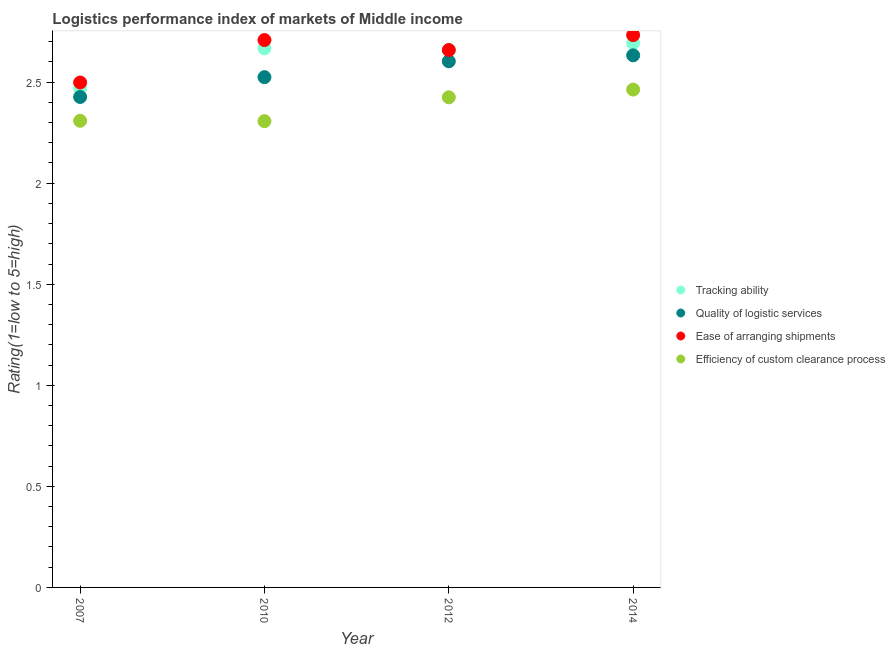How many different coloured dotlines are there?
Offer a very short reply. 4. Is the number of dotlines equal to the number of legend labels?
Provide a succinct answer. Yes. What is the lpi rating of efficiency of custom clearance process in 2007?
Make the answer very short. 2.31. Across all years, what is the maximum lpi rating of quality of logistic services?
Your response must be concise. 2.63. Across all years, what is the minimum lpi rating of tracking ability?
Ensure brevity in your answer.  2.47. In which year was the lpi rating of quality of logistic services minimum?
Provide a short and direct response. 2007. What is the total lpi rating of efficiency of custom clearance process in the graph?
Your answer should be compact. 9.5. What is the difference between the lpi rating of efficiency of custom clearance process in 2007 and that in 2012?
Keep it short and to the point. -0.12. What is the difference between the lpi rating of efficiency of custom clearance process in 2014 and the lpi rating of tracking ability in 2012?
Provide a short and direct response. -0.2. What is the average lpi rating of quality of logistic services per year?
Your response must be concise. 2.55. In the year 2007, what is the difference between the lpi rating of ease of arranging shipments and lpi rating of tracking ability?
Your response must be concise. 0.03. In how many years, is the lpi rating of tracking ability greater than 0.30000000000000004?
Your response must be concise. 4. What is the ratio of the lpi rating of tracking ability in 2010 to that in 2012?
Ensure brevity in your answer.  1. Is the difference between the lpi rating of efficiency of custom clearance process in 2012 and 2014 greater than the difference between the lpi rating of quality of logistic services in 2012 and 2014?
Offer a very short reply. No. What is the difference between the highest and the second highest lpi rating of ease of arranging shipments?
Provide a succinct answer. 0.02. What is the difference between the highest and the lowest lpi rating of quality of logistic services?
Ensure brevity in your answer.  0.21. In how many years, is the lpi rating of quality of logistic services greater than the average lpi rating of quality of logistic services taken over all years?
Provide a succinct answer. 2. Is it the case that in every year, the sum of the lpi rating of quality of logistic services and lpi rating of ease of arranging shipments is greater than the sum of lpi rating of tracking ability and lpi rating of efficiency of custom clearance process?
Provide a short and direct response. No. Does the lpi rating of tracking ability monotonically increase over the years?
Your answer should be compact. No. How many years are there in the graph?
Offer a very short reply. 4. Where does the legend appear in the graph?
Ensure brevity in your answer.  Center right. What is the title of the graph?
Provide a succinct answer. Logistics performance index of markets of Middle income. Does "Business regulatory environment" appear as one of the legend labels in the graph?
Provide a succinct answer. No. What is the label or title of the X-axis?
Keep it short and to the point. Year. What is the label or title of the Y-axis?
Your answer should be compact. Rating(1=low to 5=high). What is the Rating(1=low to 5=high) in Tracking ability in 2007?
Keep it short and to the point. 2.47. What is the Rating(1=low to 5=high) in Quality of logistic services in 2007?
Keep it short and to the point. 2.43. What is the Rating(1=low to 5=high) of Ease of arranging shipments in 2007?
Provide a short and direct response. 2.5. What is the Rating(1=low to 5=high) in Efficiency of custom clearance process in 2007?
Offer a very short reply. 2.31. What is the Rating(1=low to 5=high) in Tracking ability in 2010?
Offer a terse response. 2.67. What is the Rating(1=low to 5=high) of Quality of logistic services in 2010?
Give a very brief answer. 2.52. What is the Rating(1=low to 5=high) of Ease of arranging shipments in 2010?
Provide a short and direct response. 2.71. What is the Rating(1=low to 5=high) in Efficiency of custom clearance process in 2010?
Your answer should be very brief. 2.31. What is the Rating(1=low to 5=high) of Tracking ability in 2012?
Provide a short and direct response. 2.66. What is the Rating(1=low to 5=high) of Quality of logistic services in 2012?
Provide a succinct answer. 2.6. What is the Rating(1=low to 5=high) of Ease of arranging shipments in 2012?
Give a very brief answer. 2.66. What is the Rating(1=low to 5=high) of Efficiency of custom clearance process in 2012?
Provide a short and direct response. 2.42. What is the Rating(1=low to 5=high) of Tracking ability in 2014?
Make the answer very short. 2.69. What is the Rating(1=low to 5=high) of Quality of logistic services in 2014?
Make the answer very short. 2.63. What is the Rating(1=low to 5=high) of Ease of arranging shipments in 2014?
Your answer should be very brief. 2.73. What is the Rating(1=low to 5=high) in Efficiency of custom clearance process in 2014?
Provide a succinct answer. 2.46. Across all years, what is the maximum Rating(1=low to 5=high) in Tracking ability?
Your answer should be compact. 2.69. Across all years, what is the maximum Rating(1=low to 5=high) of Quality of logistic services?
Offer a very short reply. 2.63. Across all years, what is the maximum Rating(1=low to 5=high) of Ease of arranging shipments?
Offer a very short reply. 2.73. Across all years, what is the maximum Rating(1=low to 5=high) in Efficiency of custom clearance process?
Provide a succinct answer. 2.46. Across all years, what is the minimum Rating(1=low to 5=high) in Tracking ability?
Give a very brief answer. 2.47. Across all years, what is the minimum Rating(1=low to 5=high) of Quality of logistic services?
Your answer should be very brief. 2.43. Across all years, what is the minimum Rating(1=low to 5=high) in Ease of arranging shipments?
Make the answer very short. 2.5. Across all years, what is the minimum Rating(1=low to 5=high) in Efficiency of custom clearance process?
Provide a succinct answer. 2.31. What is the total Rating(1=low to 5=high) of Tracking ability in the graph?
Your answer should be very brief. 10.49. What is the total Rating(1=low to 5=high) of Quality of logistic services in the graph?
Ensure brevity in your answer.  10.19. What is the total Rating(1=low to 5=high) in Ease of arranging shipments in the graph?
Give a very brief answer. 10.6. What is the total Rating(1=low to 5=high) of Efficiency of custom clearance process in the graph?
Offer a terse response. 9.5. What is the difference between the Rating(1=low to 5=high) in Tracking ability in 2007 and that in 2010?
Ensure brevity in your answer.  -0.2. What is the difference between the Rating(1=low to 5=high) of Quality of logistic services in 2007 and that in 2010?
Ensure brevity in your answer.  -0.1. What is the difference between the Rating(1=low to 5=high) in Ease of arranging shipments in 2007 and that in 2010?
Keep it short and to the point. -0.21. What is the difference between the Rating(1=low to 5=high) in Efficiency of custom clearance process in 2007 and that in 2010?
Make the answer very short. 0. What is the difference between the Rating(1=low to 5=high) in Tracking ability in 2007 and that in 2012?
Ensure brevity in your answer.  -0.19. What is the difference between the Rating(1=low to 5=high) in Quality of logistic services in 2007 and that in 2012?
Your answer should be compact. -0.18. What is the difference between the Rating(1=low to 5=high) in Ease of arranging shipments in 2007 and that in 2012?
Your response must be concise. -0.16. What is the difference between the Rating(1=low to 5=high) of Efficiency of custom clearance process in 2007 and that in 2012?
Provide a succinct answer. -0.12. What is the difference between the Rating(1=low to 5=high) in Tracking ability in 2007 and that in 2014?
Provide a short and direct response. -0.22. What is the difference between the Rating(1=low to 5=high) in Quality of logistic services in 2007 and that in 2014?
Offer a terse response. -0.21. What is the difference between the Rating(1=low to 5=high) of Ease of arranging shipments in 2007 and that in 2014?
Keep it short and to the point. -0.23. What is the difference between the Rating(1=low to 5=high) of Efficiency of custom clearance process in 2007 and that in 2014?
Keep it short and to the point. -0.15. What is the difference between the Rating(1=low to 5=high) of Tracking ability in 2010 and that in 2012?
Make the answer very short. 0.01. What is the difference between the Rating(1=low to 5=high) in Quality of logistic services in 2010 and that in 2012?
Your response must be concise. -0.08. What is the difference between the Rating(1=low to 5=high) in Ease of arranging shipments in 2010 and that in 2012?
Offer a very short reply. 0.05. What is the difference between the Rating(1=low to 5=high) in Efficiency of custom clearance process in 2010 and that in 2012?
Offer a terse response. -0.12. What is the difference between the Rating(1=low to 5=high) in Tracking ability in 2010 and that in 2014?
Offer a terse response. -0.03. What is the difference between the Rating(1=low to 5=high) of Quality of logistic services in 2010 and that in 2014?
Offer a very short reply. -0.11. What is the difference between the Rating(1=low to 5=high) in Ease of arranging shipments in 2010 and that in 2014?
Keep it short and to the point. -0.02. What is the difference between the Rating(1=low to 5=high) of Efficiency of custom clearance process in 2010 and that in 2014?
Your response must be concise. -0.16. What is the difference between the Rating(1=low to 5=high) in Tracking ability in 2012 and that in 2014?
Ensure brevity in your answer.  -0.03. What is the difference between the Rating(1=low to 5=high) of Quality of logistic services in 2012 and that in 2014?
Keep it short and to the point. -0.03. What is the difference between the Rating(1=low to 5=high) of Ease of arranging shipments in 2012 and that in 2014?
Offer a very short reply. -0.07. What is the difference between the Rating(1=low to 5=high) of Efficiency of custom clearance process in 2012 and that in 2014?
Your answer should be compact. -0.04. What is the difference between the Rating(1=low to 5=high) of Tracking ability in 2007 and the Rating(1=low to 5=high) of Quality of logistic services in 2010?
Make the answer very short. -0.06. What is the difference between the Rating(1=low to 5=high) of Tracking ability in 2007 and the Rating(1=low to 5=high) of Ease of arranging shipments in 2010?
Keep it short and to the point. -0.24. What is the difference between the Rating(1=low to 5=high) of Tracking ability in 2007 and the Rating(1=low to 5=high) of Efficiency of custom clearance process in 2010?
Ensure brevity in your answer.  0.16. What is the difference between the Rating(1=low to 5=high) in Quality of logistic services in 2007 and the Rating(1=low to 5=high) in Ease of arranging shipments in 2010?
Your answer should be very brief. -0.28. What is the difference between the Rating(1=low to 5=high) in Quality of logistic services in 2007 and the Rating(1=low to 5=high) in Efficiency of custom clearance process in 2010?
Offer a terse response. 0.12. What is the difference between the Rating(1=low to 5=high) of Ease of arranging shipments in 2007 and the Rating(1=low to 5=high) of Efficiency of custom clearance process in 2010?
Your answer should be very brief. 0.19. What is the difference between the Rating(1=low to 5=high) in Tracking ability in 2007 and the Rating(1=low to 5=high) in Quality of logistic services in 2012?
Offer a very short reply. -0.13. What is the difference between the Rating(1=low to 5=high) of Tracking ability in 2007 and the Rating(1=low to 5=high) of Ease of arranging shipments in 2012?
Offer a very short reply. -0.19. What is the difference between the Rating(1=low to 5=high) of Tracking ability in 2007 and the Rating(1=low to 5=high) of Efficiency of custom clearance process in 2012?
Keep it short and to the point. 0.04. What is the difference between the Rating(1=low to 5=high) of Quality of logistic services in 2007 and the Rating(1=low to 5=high) of Ease of arranging shipments in 2012?
Keep it short and to the point. -0.23. What is the difference between the Rating(1=low to 5=high) in Quality of logistic services in 2007 and the Rating(1=low to 5=high) in Efficiency of custom clearance process in 2012?
Provide a succinct answer. 0. What is the difference between the Rating(1=low to 5=high) in Ease of arranging shipments in 2007 and the Rating(1=low to 5=high) in Efficiency of custom clearance process in 2012?
Give a very brief answer. 0.07. What is the difference between the Rating(1=low to 5=high) in Tracking ability in 2007 and the Rating(1=low to 5=high) in Quality of logistic services in 2014?
Keep it short and to the point. -0.16. What is the difference between the Rating(1=low to 5=high) of Tracking ability in 2007 and the Rating(1=low to 5=high) of Ease of arranging shipments in 2014?
Offer a very short reply. -0.26. What is the difference between the Rating(1=low to 5=high) in Tracking ability in 2007 and the Rating(1=low to 5=high) in Efficiency of custom clearance process in 2014?
Keep it short and to the point. 0.01. What is the difference between the Rating(1=low to 5=high) in Quality of logistic services in 2007 and the Rating(1=low to 5=high) in Ease of arranging shipments in 2014?
Your answer should be very brief. -0.31. What is the difference between the Rating(1=low to 5=high) of Quality of logistic services in 2007 and the Rating(1=low to 5=high) of Efficiency of custom clearance process in 2014?
Give a very brief answer. -0.04. What is the difference between the Rating(1=low to 5=high) in Ease of arranging shipments in 2007 and the Rating(1=low to 5=high) in Efficiency of custom clearance process in 2014?
Offer a terse response. 0.04. What is the difference between the Rating(1=low to 5=high) of Tracking ability in 2010 and the Rating(1=low to 5=high) of Quality of logistic services in 2012?
Keep it short and to the point. 0.06. What is the difference between the Rating(1=low to 5=high) in Tracking ability in 2010 and the Rating(1=low to 5=high) in Ease of arranging shipments in 2012?
Give a very brief answer. 0.01. What is the difference between the Rating(1=low to 5=high) in Tracking ability in 2010 and the Rating(1=low to 5=high) in Efficiency of custom clearance process in 2012?
Keep it short and to the point. 0.24. What is the difference between the Rating(1=low to 5=high) of Quality of logistic services in 2010 and the Rating(1=low to 5=high) of Ease of arranging shipments in 2012?
Your answer should be compact. -0.13. What is the difference between the Rating(1=low to 5=high) in Quality of logistic services in 2010 and the Rating(1=low to 5=high) in Efficiency of custom clearance process in 2012?
Keep it short and to the point. 0.1. What is the difference between the Rating(1=low to 5=high) in Ease of arranging shipments in 2010 and the Rating(1=low to 5=high) in Efficiency of custom clearance process in 2012?
Your answer should be compact. 0.28. What is the difference between the Rating(1=low to 5=high) in Tracking ability in 2010 and the Rating(1=low to 5=high) in Quality of logistic services in 2014?
Ensure brevity in your answer.  0.03. What is the difference between the Rating(1=low to 5=high) in Tracking ability in 2010 and the Rating(1=low to 5=high) in Ease of arranging shipments in 2014?
Keep it short and to the point. -0.07. What is the difference between the Rating(1=low to 5=high) in Tracking ability in 2010 and the Rating(1=low to 5=high) in Efficiency of custom clearance process in 2014?
Provide a succinct answer. 0.2. What is the difference between the Rating(1=low to 5=high) in Quality of logistic services in 2010 and the Rating(1=low to 5=high) in Ease of arranging shipments in 2014?
Give a very brief answer. -0.21. What is the difference between the Rating(1=low to 5=high) of Quality of logistic services in 2010 and the Rating(1=low to 5=high) of Efficiency of custom clearance process in 2014?
Offer a very short reply. 0.06. What is the difference between the Rating(1=low to 5=high) in Ease of arranging shipments in 2010 and the Rating(1=low to 5=high) in Efficiency of custom clearance process in 2014?
Provide a succinct answer. 0.24. What is the difference between the Rating(1=low to 5=high) of Tracking ability in 2012 and the Rating(1=low to 5=high) of Quality of logistic services in 2014?
Offer a very short reply. 0.03. What is the difference between the Rating(1=low to 5=high) of Tracking ability in 2012 and the Rating(1=low to 5=high) of Ease of arranging shipments in 2014?
Provide a short and direct response. -0.07. What is the difference between the Rating(1=low to 5=high) in Tracking ability in 2012 and the Rating(1=low to 5=high) in Efficiency of custom clearance process in 2014?
Make the answer very short. 0.2. What is the difference between the Rating(1=low to 5=high) of Quality of logistic services in 2012 and the Rating(1=low to 5=high) of Ease of arranging shipments in 2014?
Your answer should be compact. -0.13. What is the difference between the Rating(1=low to 5=high) in Quality of logistic services in 2012 and the Rating(1=low to 5=high) in Efficiency of custom clearance process in 2014?
Offer a very short reply. 0.14. What is the difference between the Rating(1=low to 5=high) of Ease of arranging shipments in 2012 and the Rating(1=low to 5=high) of Efficiency of custom clearance process in 2014?
Your answer should be very brief. 0.2. What is the average Rating(1=low to 5=high) of Tracking ability per year?
Provide a succinct answer. 2.62. What is the average Rating(1=low to 5=high) of Quality of logistic services per year?
Your answer should be compact. 2.55. What is the average Rating(1=low to 5=high) of Ease of arranging shipments per year?
Your answer should be very brief. 2.65. What is the average Rating(1=low to 5=high) of Efficiency of custom clearance process per year?
Keep it short and to the point. 2.38. In the year 2007, what is the difference between the Rating(1=low to 5=high) of Tracking ability and Rating(1=low to 5=high) of Quality of logistic services?
Your answer should be compact. 0.04. In the year 2007, what is the difference between the Rating(1=low to 5=high) in Tracking ability and Rating(1=low to 5=high) in Ease of arranging shipments?
Your response must be concise. -0.03. In the year 2007, what is the difference between the Rating(1=low to 5=high) of Tracking ability and Rating(1=low to 5=high) of Efficiency of custom clearance process?
Provide a succinct answer. 0.16. In the year 2007, what is the difference between the Rating(1=low to 5=high) of Quality of logistic services and Rating(1=low to 5=high) of Ease of arranging shipments?
Offer a terse response. -0.07. In the year 2007, what is the difference between the Rating(1=low to 5=high) in Quality of logistic services and Rating(1=low to 5=high) in Efficiency of custom clearance process?
Keep it short and to the point. 0.12. In the year 2007, what is the difference between the Rating(1=low to 5=high) of Ease of arranging shipments and Rating(1=low to 5=high) of Efficiency of custom clearance process?
Give a very brief answer. 0.19. In the year 2010, what is the difference between the Rating(1=low to 5=high) of Tracking ability and Rating(1=low to 5=high) of Quality of logistic services?
Ensure brevity in your answer.  0.14. In the year 2010, what is the difference between the Rating(1=low to 5=high) of Tracking ability and Rating(1=low to 5=high) of Ease of arranging shipments?
Your response must be concise. -0.04. In the year 2010, what is the difference between the Rating(1=low to 5=high) of Tracking ability and Rating(1=low to 5=high) of Efficiency of custom clearance process?
Make the answer very short. 0.36. In the year 2010, what is the difference between the Rating(1=low to 5=high) in Quality of logistic services and Rating(1=low to 5=high) in Ease of arranging shipments?
Your answer should be compact. -0.18. In the year 2010, what is the difference between the Rating(1=low to 5=high) of Quality of logistic services and Rating(1=low to 5=high) of Efficiency of custom clearance process?
Offer a very short reply. 0.22. In the year 2010, what is the difference between the Rating(1=low to 5=high) of Ease of arranging shipments and Rating(1=low to 5=high) of Efficiency of custom clearance process?
Your answer should be compact. 0.4. In the year 2012, what is the difference between the Rating(1=low to 5=high) of Tracking ability and Rating(1=low to 5=high) of Quality of logistic services?
Provide a succinct answer. 0.06. In the year 2012, what is the difference between the Rating(1=low to 5=high) in Tracking ability and Rating(1=low to 5=high) in Ease of arranging shipments?
Your response must be concise. -0. In the year 2012, what is the difference between the Rating(1=low to 5=high) in Tracking ability and Rating(1=low to 5=high) in Efficiency of custom clearance process?
Provide a succinct answer. 0.23. In the year 2012, what is the difference between the Rating(1=low to 5=high) in Quality of logistic services and Rating(1=low to 5=high) in Ease of arranging shipments?
Make the answer very short. -0.06. In the year 2012, what is the difference between the Rating(1=low to 5=high) in Quality of logistic services and Rating(1=low to 5=high) in Efficiency of custom clearance process?
Your answer should be compact. 0.18. In the year 2012, what is the difference between the Rating(1=low to 5=high) of Ease of arranging shipments and Rating(1=low to 5=high) of Efficiency of custom clearance process?
Your response must be concise. 0.23. In the year 2014, what is the difference between the Rating(1=low to 5=high) in Tracking ability and Rating(1=low to 5=high) in Quality of logistic services?
Provide a short and direct response. 0.06. In the year 2014, what is the difference between the Rating(1=low to 5=high) of Tracking ability and Rating(1=low to 5=high) of Ease of arranging shipments?
Ensure brevity in your answer.  -0.04. In the year 2014, what is the difference between the Rating(1=low to 5=high) of Tracking ability and Rating(1=low to 5=high) of Efficiency of custom clearance process?
Provide a short and direct response. 0.23. In the year 2014, what is the difference between the Rating(1=low to 5=high) in Quality of logistic services and Rating(1=low to 5=high) in Efficiency of custom clearance process?
Ensure brevity in your answer.  0.17. In the year 2014, what is the difference between the Rating(1=low to 5=high) in Ease of arranging shipments and Rating(1=low to 5=high) in Efficiency of custom clearance process?
Provide a succinct answer. 0.27. What is the ratio of the Rating(1=low to 5=high) of Tracking ability in 2007 to that in 2010?
Provide a succinct answer. 0.93. What is the ratio of the Rating(1=low to 5=high) in Quality of logistic services in 2007 to that in 2010?
Provide a short and direct response. 0.96. What is the ratio of the Rating(1=low to 5=high) of Ease of arranging shipments in 2007 to that in 2010?
Offer a terse response. 0.92. What is the ratio of the Rating(1=low to 5=high) of Efficiency of custom clearance process in 2007 to that in 2010?
Your answer should be very brief. 1. What is the ratio of the Rating(1=low to 5=high) of Quality of logistic services in 2007 to that in 2012?
Make the answer very short. 0.93. What is the ratio of the Rating(1=low to 5=high) in Ease of arranging shipments in 2007 to that in 2012?
Offer a terse response. 0.94. What is the ratio of the Rating(1=low to 5=high) in Efficiency of custom clearance process in 2007 to that in 2012?
Offer a terse response. 0.95. What is the ratio of the Rating(1=low to 5=high) in Tracking ability in 2007 to that in 2014?
Your response must be concise. 0.92. What is the ratio of the Rating(1=low to 5=high) of Quality of logistic services in 2007 to that in 2014?
Provide a short and direct response. 0.92. What is the ratio of the Rating(1=low to 5=high) of Ease of arranging shipments in 2007 to that in 2014?
Your answer should be very brief. 0.91. What is the ratio of the Rating(1=low to 5=high) of Efficiency of custom clearance process in 2007 to that in 2014?
Give a very brief answer. 0.94. What is the ratio of the Rating(1=low to 5=high) of Quality of logistic services in 2010 to that in 2012?
Offer a terse response. 0.97. What is the ratio of the Rating(1=low to 5=high) in Ease of arranging shipments in 2010 to that in 2012?
Offer a terse response. 1.02. What is the ratio of the Rating(1=low to 5=high) of Efficiency of custom clearance process in 2010 to that in 2012?
Keep it short and to the point. 0.95. What is the ratio of the Rating(1=low to 5=high) in Ease of arranging shipments in 2010 to that in 2014?
Provide a succinct answer. 0.99. What is the ratio of the Rating(1=low to 5=high) of Efficiency of custom clearance process in 2010 to that in 2014?
Offer a terse response. 0.94. What is the ratio of the Rating(1=low to 5=high) in Tracking ability in 2012 to that in 2014?
Offer a very short reply. 0.99. What is the ratio of the Rating(1=low to 5=high) in Quality of logistic services in 2012 to that in 2014?
Make the answer very short. 0.99. What is the ratio of the Rating(1=low to 5=high) in Efficiency of custom clearance process in 2012 to that in 2014?
Your answer should be very brief. 0.98. What is the difference between the highest and the second highest Rating(1=low to 5=high) in Tracking ability?
Your response must be concise. 0.03. What is the difference between the highest and the second highest Rating(1=low to 5=high) of Quality of logistic services?
Make the answer very short. 0.03. What is the difference between the highest and the second highest Rating(1=low to 5=high) in Ease of arranging shipments?
Your answer should be very brief. 0.02. What is the difference between the highest and the second highest Rating(1=low to 5=high) in Efficiency of custom clearance process?
Your answer should be compact. 0.04. What is the difference between the highest and the lowest Rating(1=low to 5=high) of Tracking ability?
Your response must be concise. 0.22. What is the difference between the highest and the lowest Rating(1=low to 5=high) of Quality of logistic services?
Give a very brief answer. 0.21. What is the difference between the highest and the lowest Rating(1=low to 5=high) of Ease of arranging shipments?
Ensure brevity in your answer.  0.23. What is the difference between the highest and the lowest Rating(1=low to 5=high) of Efficiency of custom clearance process?
Make the answer very short. 0.16. 